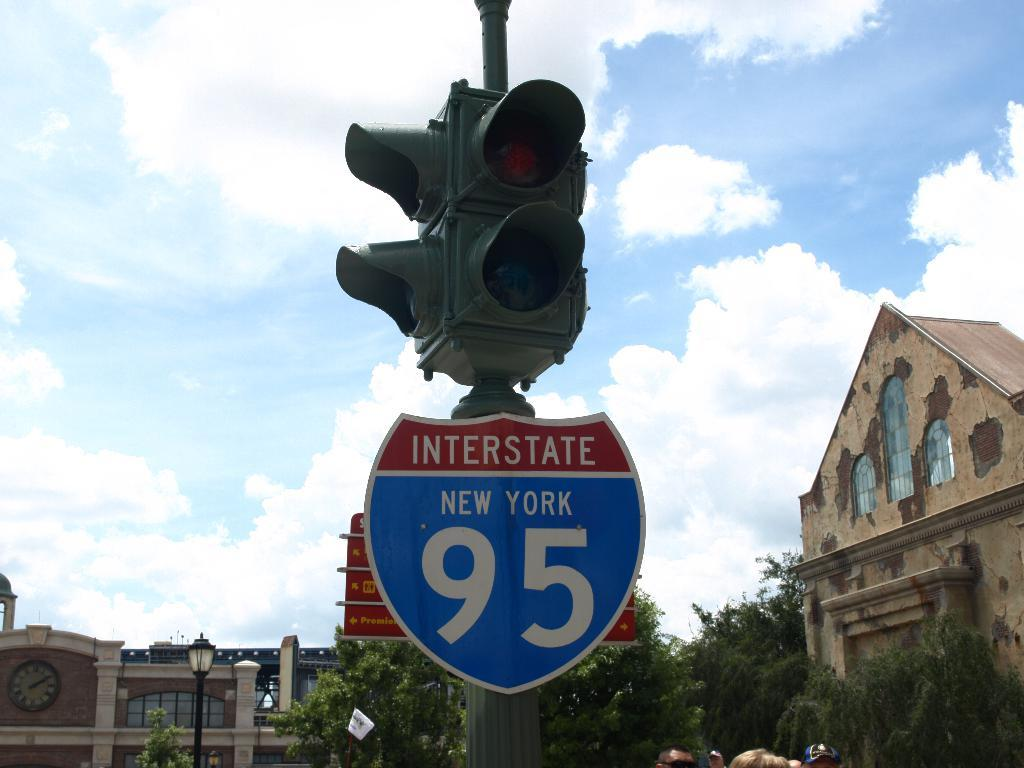<image>
Relay a brief, clear account of the picture shown. Just below a stop light is a road sign that says Interstate New York 95. 